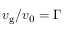Convert formula to latex. <formula><loc_0><loc_0><loc_500><loc_500>v _ { g } / v _ { 0 } = \Gamma</formula> 